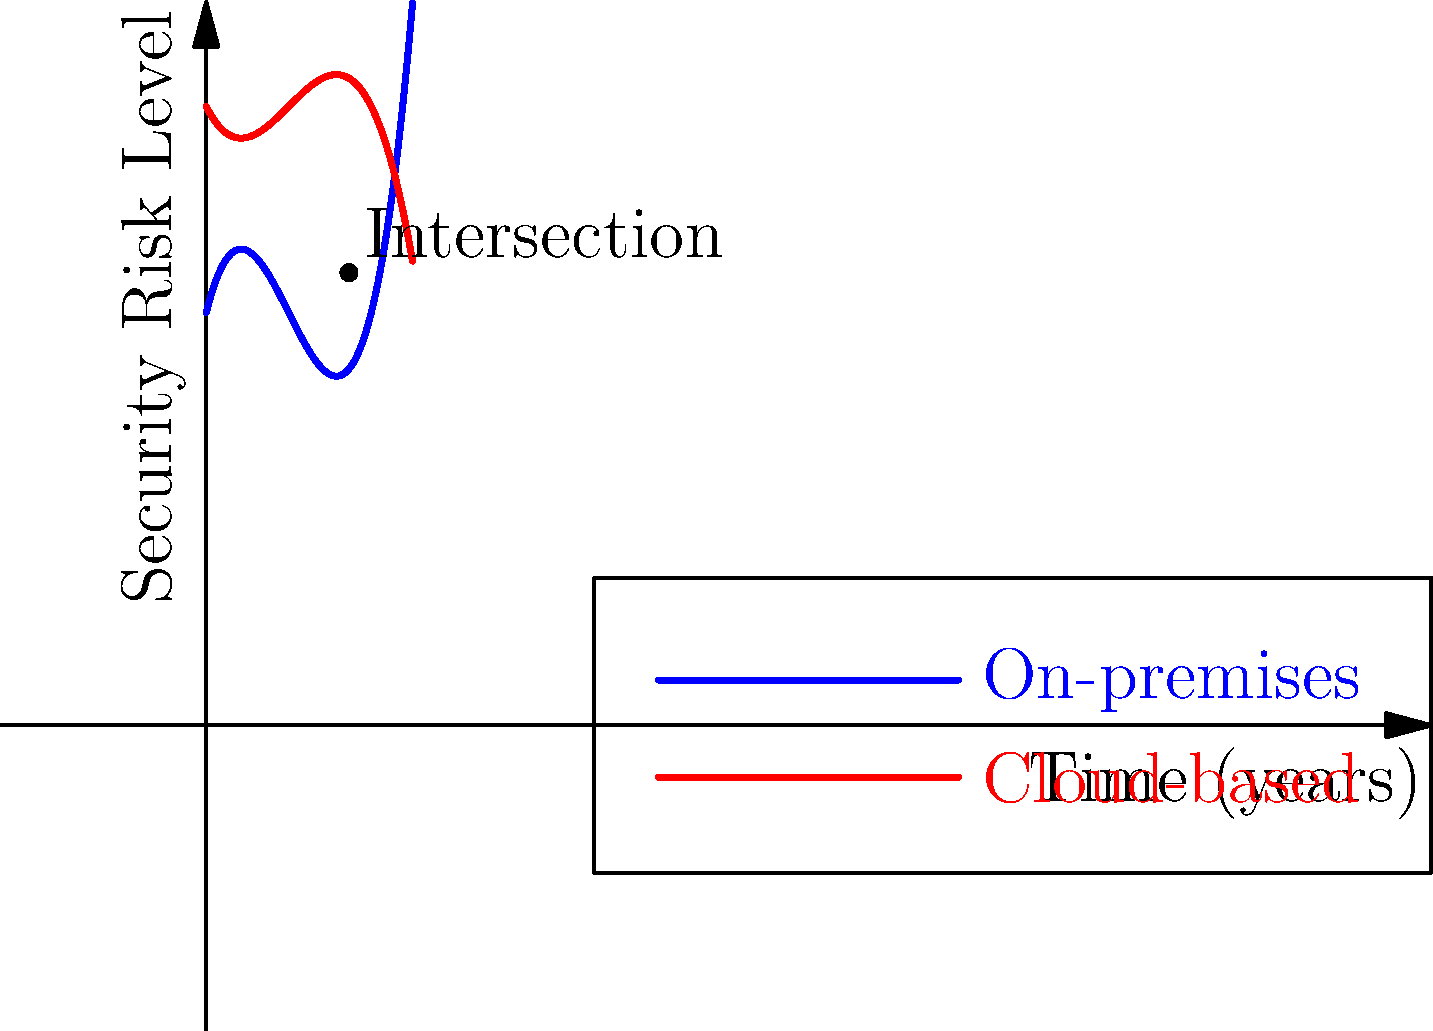The graph shows the security risk levels for on-premises and cloud-based systems over time. At what point in time (in years) do the security risks of on-premises and cloud-based systems become equal, and what is the corresponding risk level? To solve this problem, we need to follow these steps:

1. Identify the equations of the two curves:
   On-premises: $f(x) = 0.5x^3 - 3x^2 + 4x + 10$
   Cloud-based: $g(x) = -0.25x^3 + 1.5x^2 - 2x + 15$

2. Find the intersection point by setting the equations equal:
   $0.5x^3 - 3x^2 + 4x + 10 = -0.25x^3 + 1.5x^2 - 2x + 15$

3. Simplify the equation:
   $0.75x^3 - 4.5x^2 + 6x - 5 = 0$

4. Solve this equation numerically (as it's a cubic equation):
   The solution is approximately $x = 3.46$ years

5. Calculate the risk level at this point by substituting x into either equation:
   $f(3.46) = g(3.46) \approx 10.97$

Therefore, the security risks become equal after approximately 3.46 years, at a risk level of about 10.97.
Answer: 3.46 years, risk level 10.97 